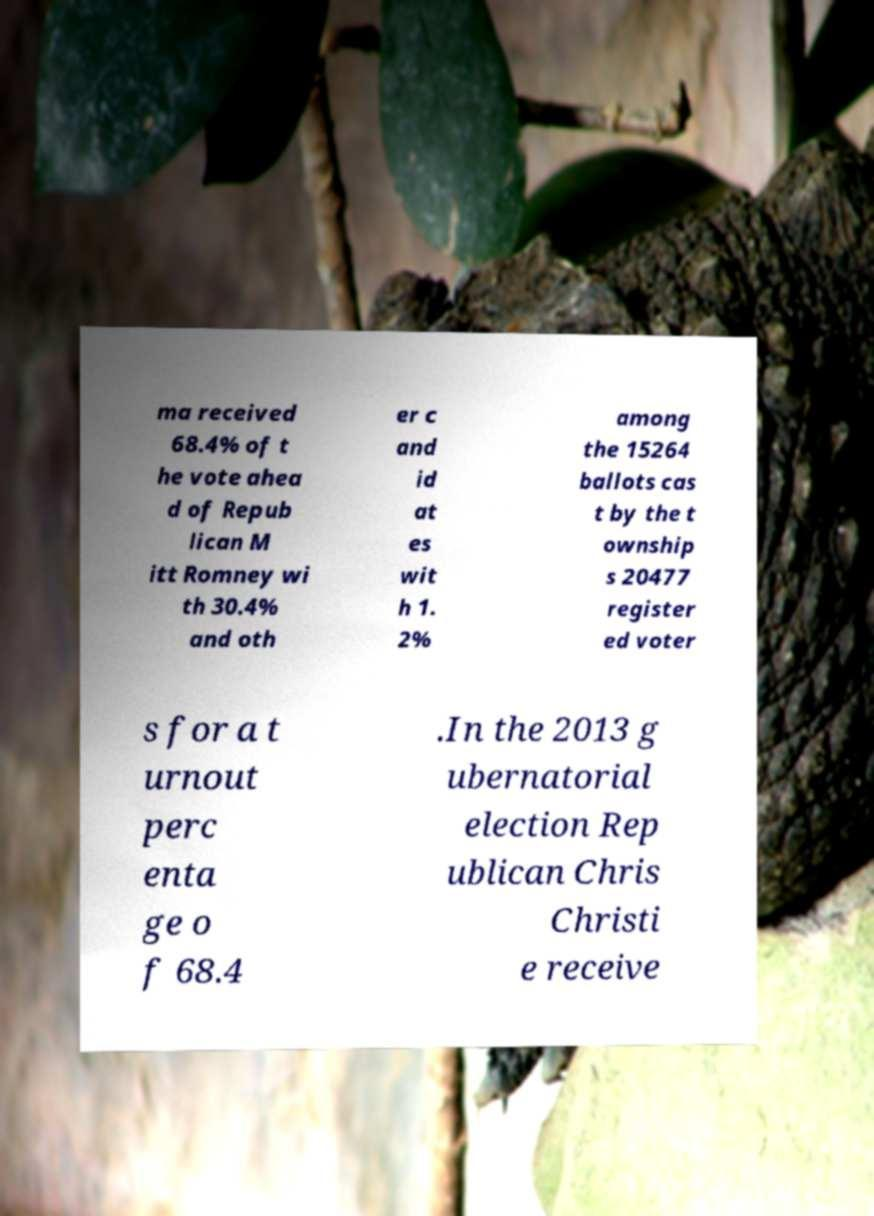For documentation purposes, I need the text within this image transcribed. Could you provide that? ma received 68.4% of t he vote ahea d of Repub lican M itt Romney wi th 30.4% and oth er c and id at es wit h 1. 2% among the 15264 ballots cas t by the t ownship s 20477 register ed voter s for a t urnout perc enta ge o f 68.4 .In the 2013 g ubernatorial election Rep ublican Chris Christi e receive 